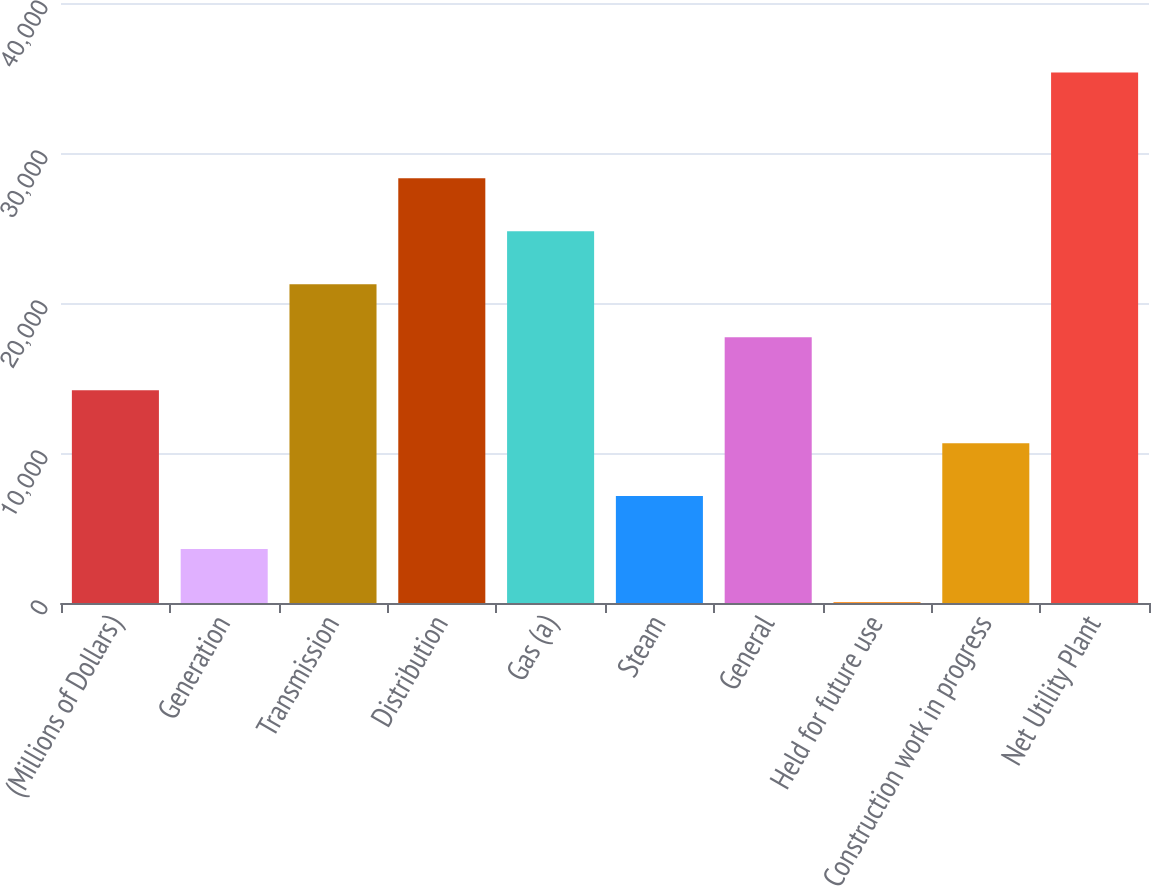Convert chart to OTSL. <chart><loc_0><loc_0><loc_500><loc_500><bar_chart><fcel>(Millions of Dollars)<fcel>Generation<fcel>Transmission<fcel>Distribution<fcel>Gas (a)<fcel>Steam<fcel>General<fcel>Held for future use<fcel>Construction work in progress<fcel>Net Utility Plant<nl><fcel>14188.2<fcel>3597.3<fcel>21248.8<fcel>28309.4<fcel>24779.1<fcel>7127.6<fcel>17718.5<fcel>67<fcel>10657.9<fcel>35370<nl></chart> 